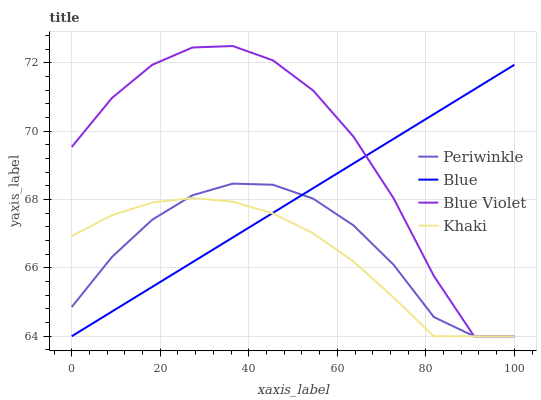Does Khaki have the minimum area under the curve?
Answer yes or no. Yes. Does Blue Violet have the maximum area under the curve?
Answer yes or no. Yes. Does Periwinkle have the minimum area under the curve?
Answer yes or no. No. Does Periwinkle have the maximum area under the curve?
Answer yes or no. No. Is Blue the smoothest?
Answer yes or no. Yes. Is Blue Violet the roughest?
Answer yes or no. Yes. Is Khaki the smoothest?
Answer yes or no. No. Is Khaki the roughest?
Answer yes or no. No. Does Blue have the lowest value?
Answer yes or no. Yes. Does Blue Violet have the highest value?
Answer yes or no. Yes. Does Periwinkle have the highest value?
Answer yes or no. No. Does Blue Violet intersect Periwinkle?
Answer yes or no. Yes. Is Blue Violet less than Periwinkle?
Answer yes or no. No. Is Blue Violet greater than Periwinkle?
Answer yes or no. No. 